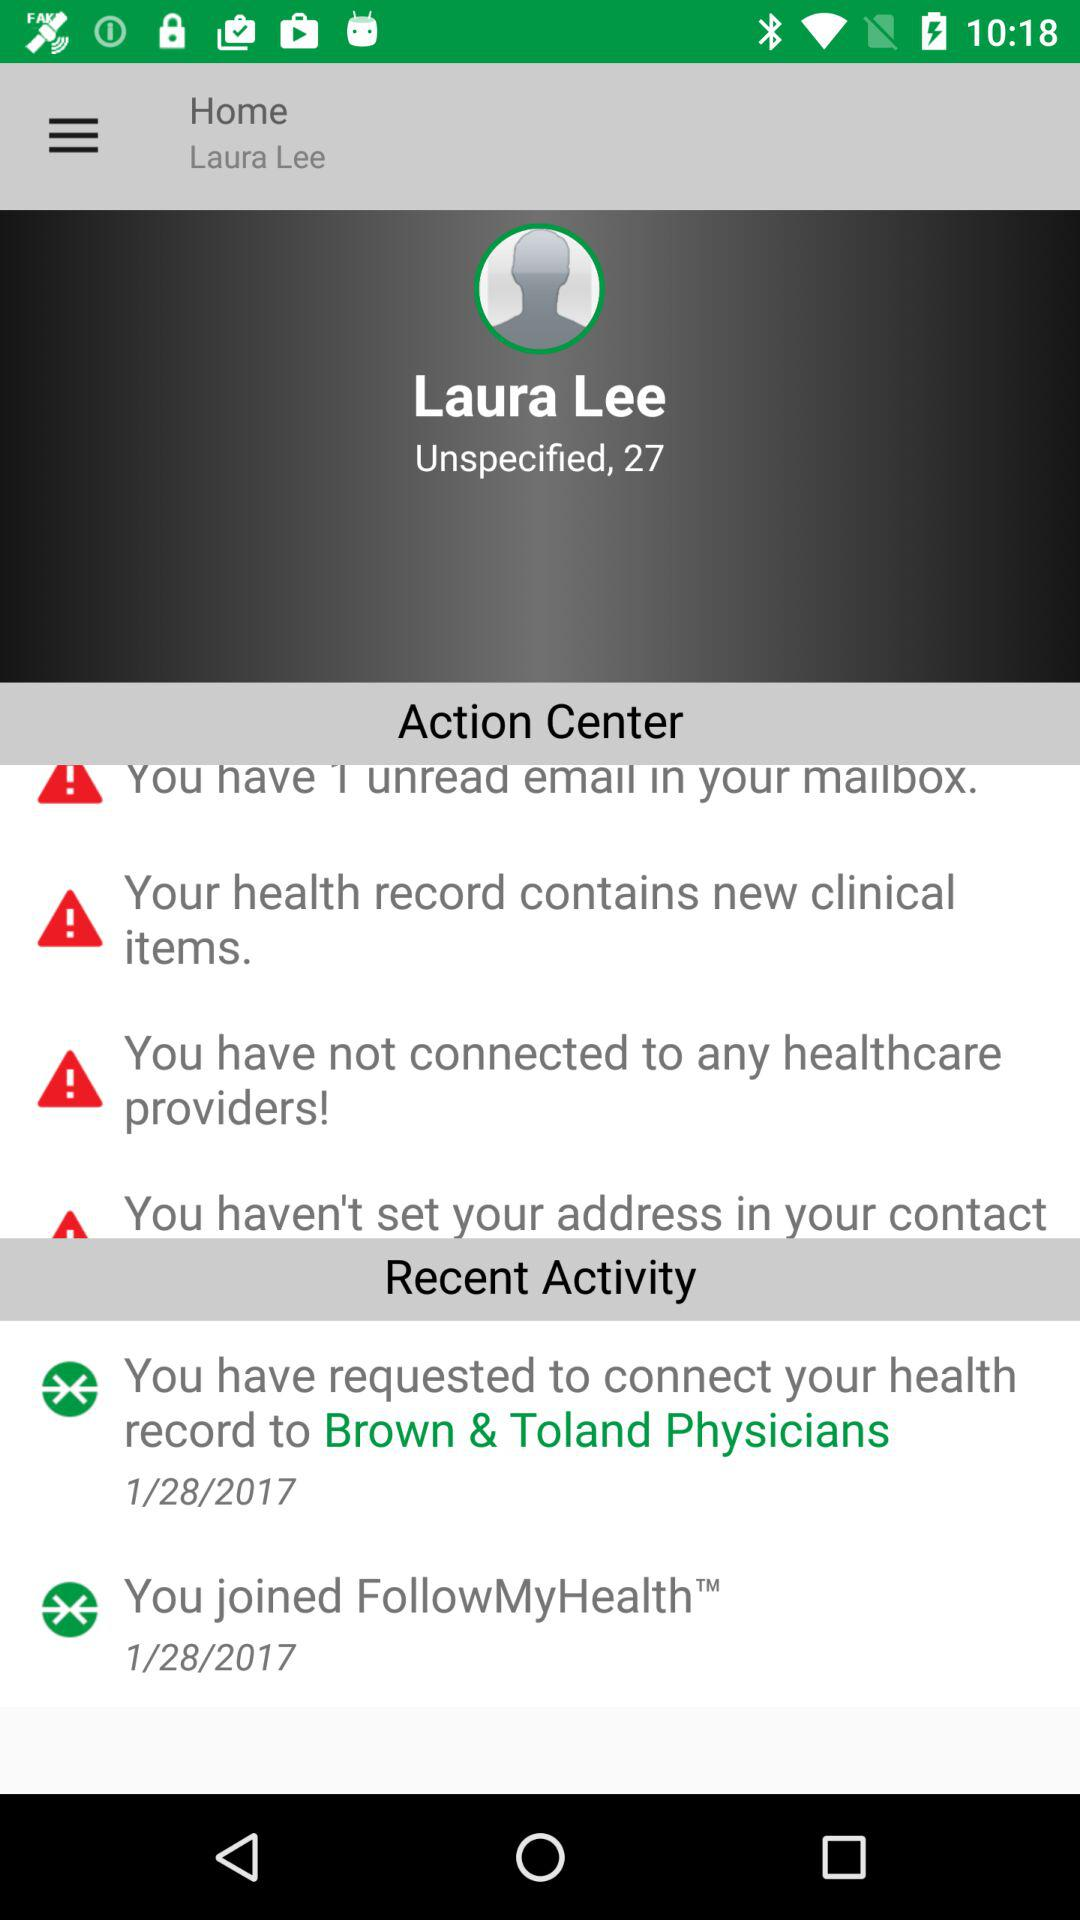What is the name of the user? The name of the user is Laura Lee. 